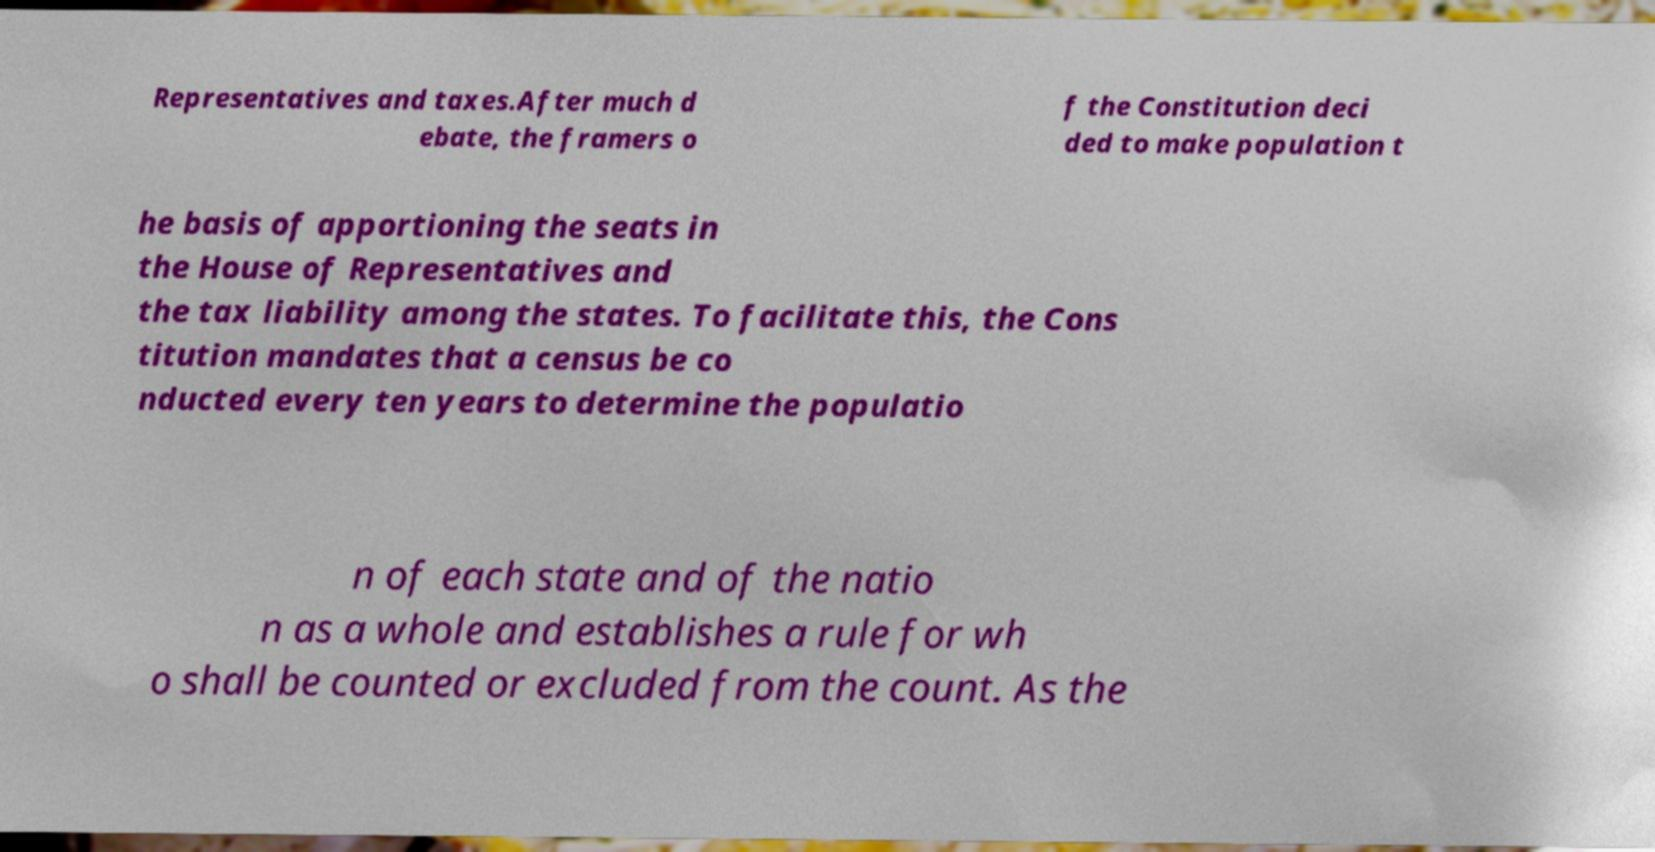There's text embedded in this image that I need extracted. Can you transcribe it verbatim? Representatives and taxes.After much d ebate, the framers o f the Constitution deci ded to make population t he basis of apportioning the seats in the House of Representatives and the tax liability among the states. To facilitate this, the Cons titution mandates that a census be co nducted every ten years to determine the populatio n of each state and of the natio n as a whole and establishes a rule for wh o shall be counted or excluded from the count. As the 